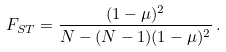Convert formula to latex. <formula><loc_0><loc_0><loc_500><loc_500>F _ { S T } = \frac { ( 1 - \mu ) ^ { 2 } } { N - ( N - 1 ) ( 1 - \mu ) ^ { 2 } } \, .</formula> 